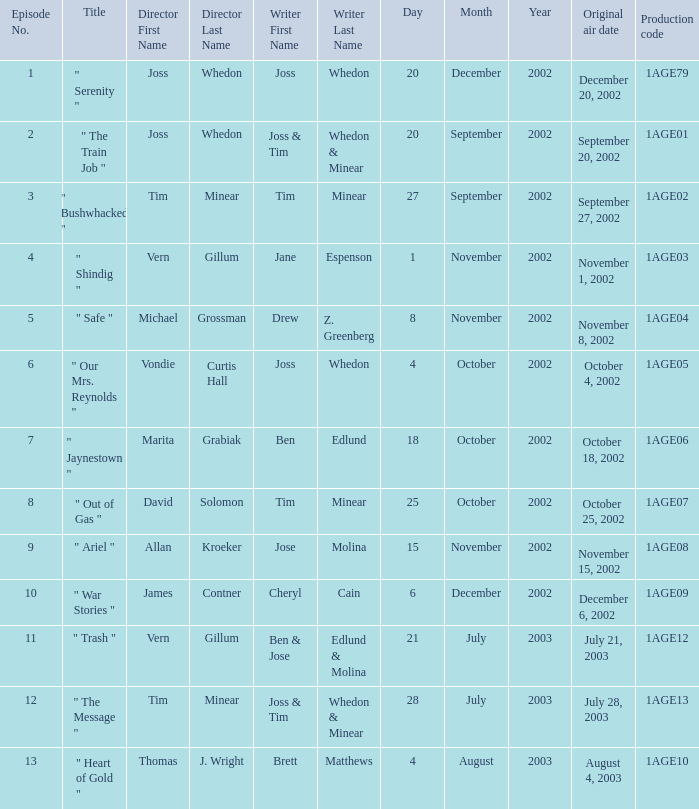Who directed episode number 3? Tim Minear. 